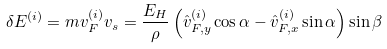Convert formula to latex. <formula><loc_0><loc_0><loc_500><loc_500>\delta E ^ { ( i ) } = m { v } _ { F } ^ { ( i ) } { v } _ { s } = \frac { E _ { H } } { \rho } \left ( \hat { v } _ { F , y } ^ { ( i ) } \cos \alpha - \hat { v } _ { F , x } ^ { ( i ) } \sin \alpha \right ) \sin \beta</formula> 